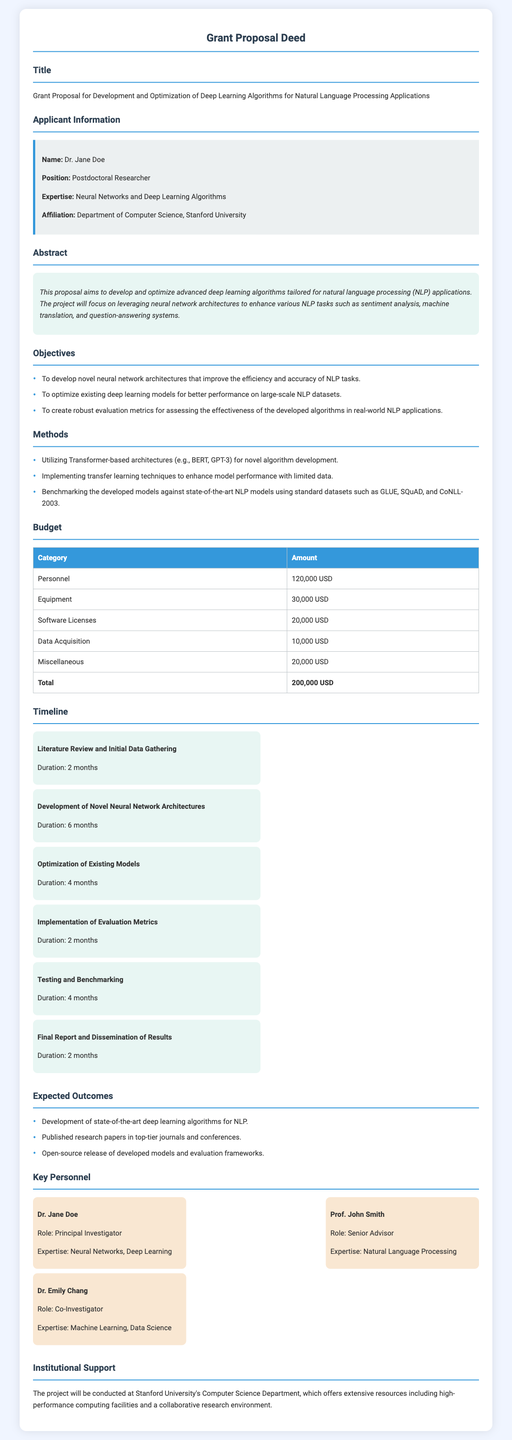what is the title of the grant proposal? The title is explicitly mentioned in the document.
Answer: Grant Proposal for Development and Optimization of Deep Learning Algorithms for Natural Language Processing Applications who is the principal investigator? The principal investigator is listed in the key personnel section of the document.
Answer: Dr. Jane Doe what is the total budget amount? The total budget is provided in the budget section of the document.
Answer: 200,000 USD how long is the timeline for the development of novel neural network architectures? The duration is specified in the timeline section related to that task.
Answer: 6 months which institution is conducting the project? The conducting institution is stated in the institutional support section.
Answer: Stanford University what is one of the objectives of the proposal? Objectives are clearly listed in the objectives section of the document.
Answer: To develop novel neural network architectures that improve the efficiency and accuracy of NLP tasks how many months is allocated for testing and benchmarking? The duration for testing and benchmarking is outlined in the timeline section of the document.
Answer: 4 months who is the senior advisor for the project? The senior advisor is mentioned in the key personnel section of the document.
Answer: Prof. John Smith what type of algorithms is the project focused on? The focus area of the algorithms is mentioned in the abstract section of the document.
Answer: Deep learning algorithms for natural language processing applications 